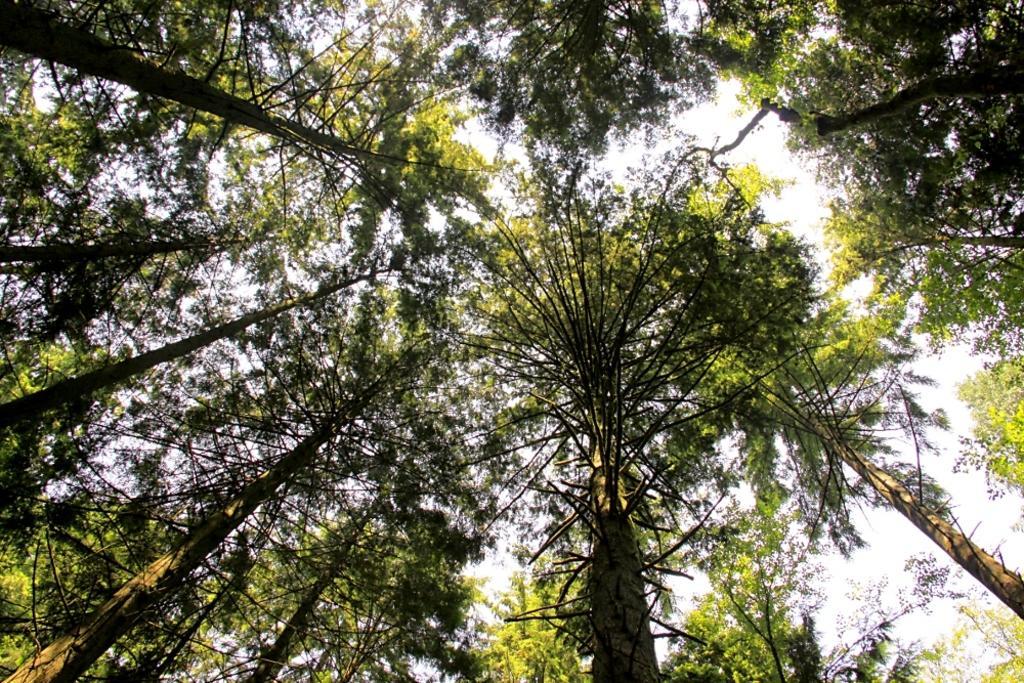Can you describe this image briefly? In this image I can see number of trees. 